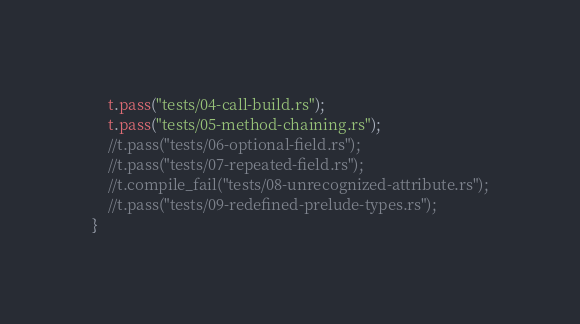Convert code to text. <code><loc_0><loc_0><loc_500><loc_500><_Rust_>    t.pass("tests/04-call-build.rs");
    t.pass("tests/05-method-chaining.rs");
    //t.pass("tests/06-optional-field.rs");
    //t.pass("tests/07-repeated-field.rs");
    //t.compile_fail("tests/08-unrecognized-attribute.rs");
    //t.pass("tests/09-redefined-prelude-types.rs");
}
</code> 